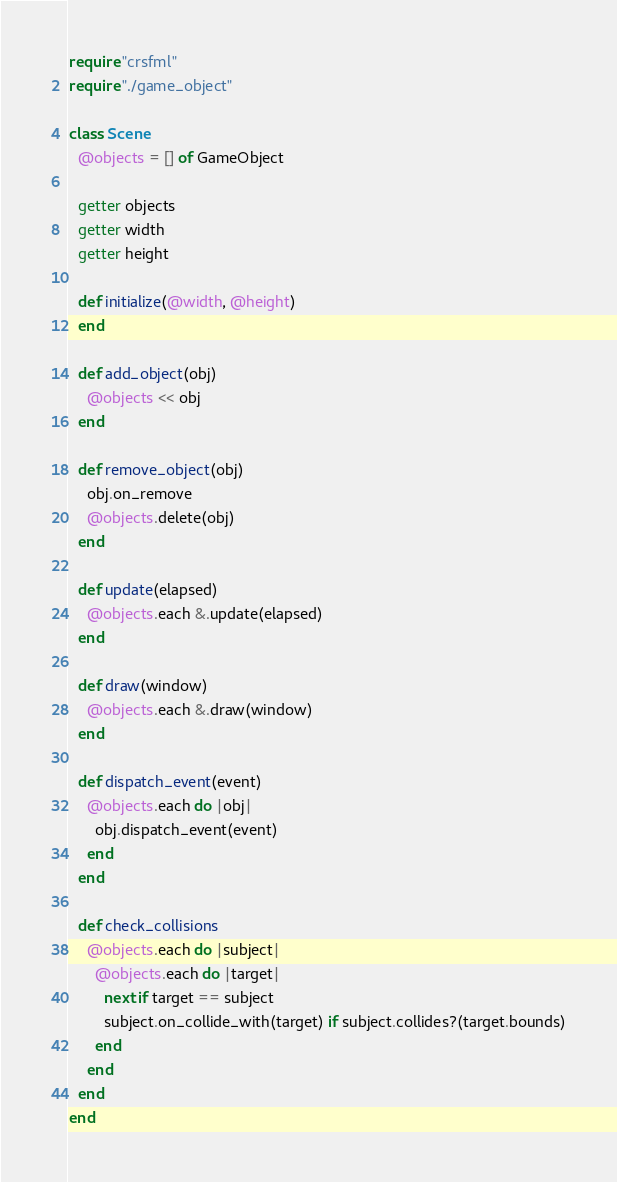<code> <loc_0><loc_0><loc_500><loc_500><_Crystal_>require "crsfml"
require "./game_object"

class Scene
  @objects = [] of GameObject

  getter objects
  getter width
  getter height

  def initialize(@width, @height)
  end

  def add_object(obj)
    @objects << obj
  end

  def remove_object(obj)
    obj.on_remove
    @objects.delete(obj)
  end

  def update(elapsed)
    @objects.each &.update(elapsed)
  end

  def draw(window)
    @objects.each &.draw(window)
  end

  def dispatch_event(event)
    @objects.each do |obj|
      obj.dispatch_event(event)
    end
  end

  def check_collisions
    @objects.each do |subject|
      @objects.each do |target|
        next if target == subject
        subject.on_collide_with(target) if subject.collides?(target.bounds)
      end
    end
  end
end
</code> 